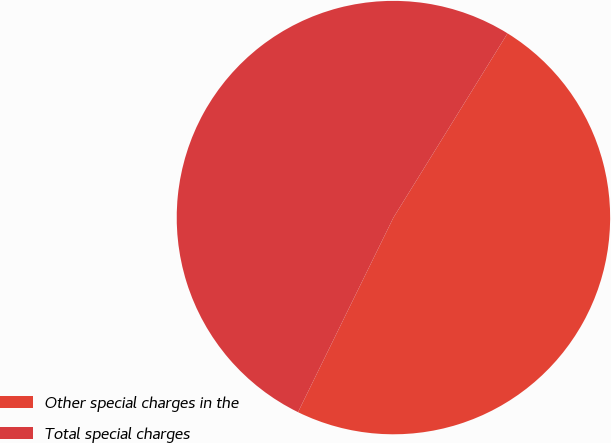Convert chart to OTSL. <chart><loc_0><loc_0><loc_500><loc_500><pie_chart><fcel>Other special charges in the<fcel>Total special charges<nl><fcel>48.43%<fcel>51.57%<nl></chart> 